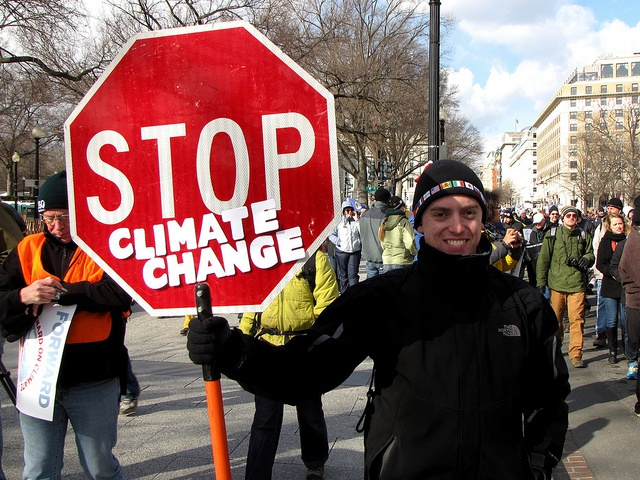Describe the objects in this image and their specific colors. I can see stop sign in darkgray, brown, white, and maroon tones, people in darkgray, black, maroon, gray, and brown tones, people in darkgray, black, white, and gray tones, people in darkgray, black, khaki, and olive tones, and people in darkgray, black, darkgreen, olive, and orange tones in this image. 